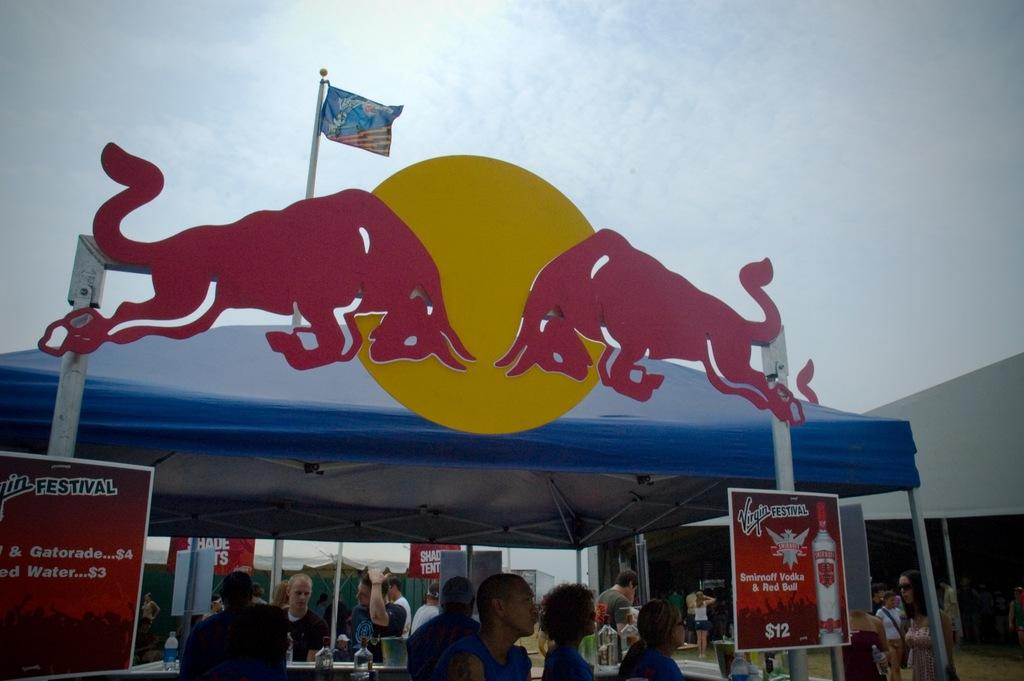Who or what can be seen in the image? There are people in the image. What structures are present in the image? There are tents, poles, and a flag in the image. What other objects can be seen in the image? There are boards and objects on tables in the image. What is the color of the sky in the image? The sky is blue and white in color. Can you tell me how many actors are running with bikes in the image? There are no actors or bikes present in the image. 